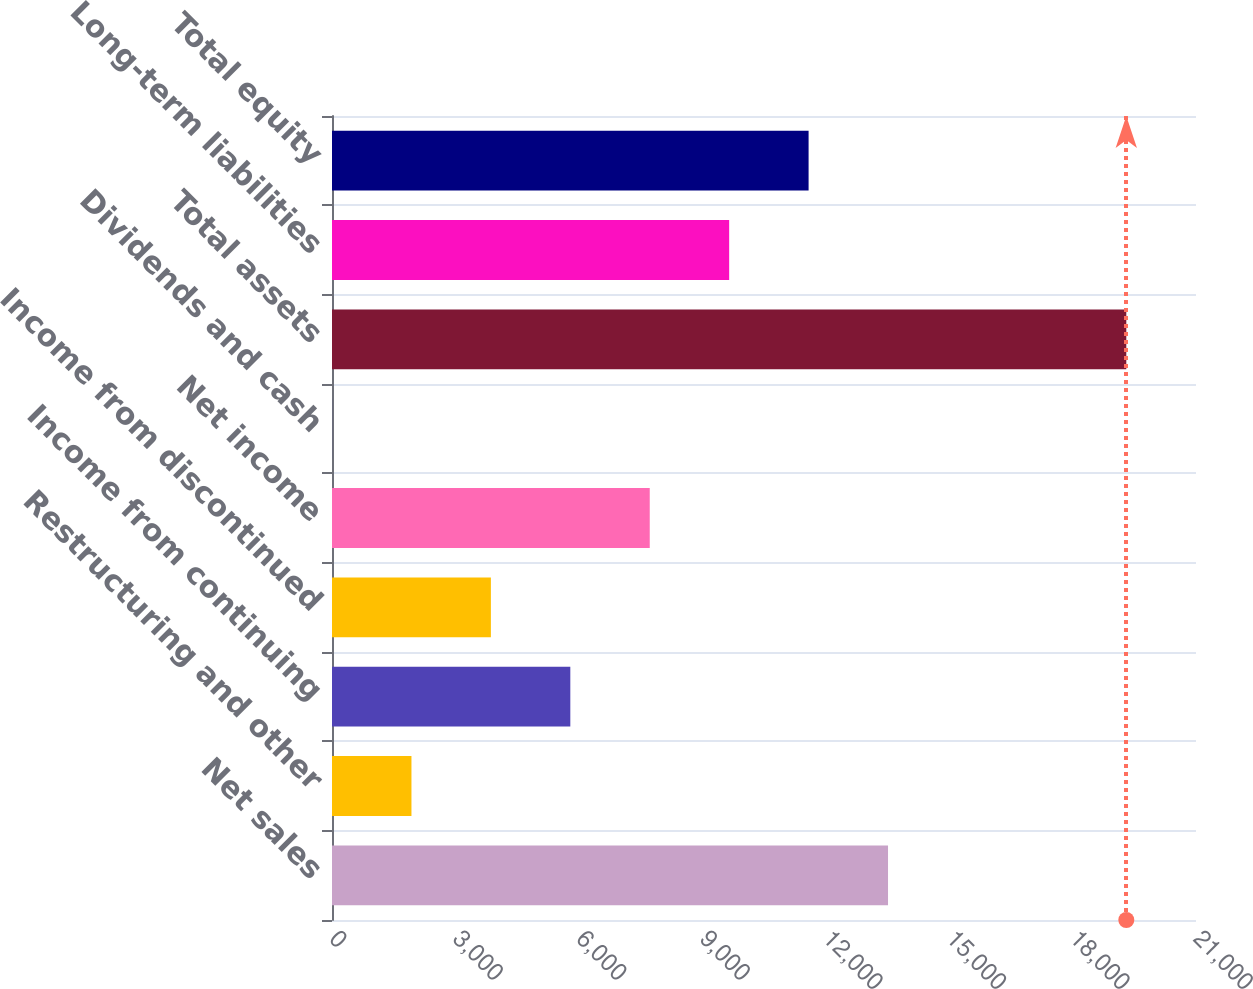Convert chart to OTSL. <chart><loc_0><loc_0><loc_500><loc_500><bar_chart><fcel>Net sales<fcel>Restructuring and other<fcel>Income from continuing<fcel>Income from discontinued<fcel>Net income<fcel>Dividends and cash<fcel>Total assets<fcel>Long-term liabilities<fcel>Total equity<nl><fcel>13514.4<fcel>1931.3<fcel>5792.34<fcel>3861.82<fcel>7722.86<fcel>0.78<fcel>19306<fcel>9653.38<fcel>11583.9<nl></chart> 